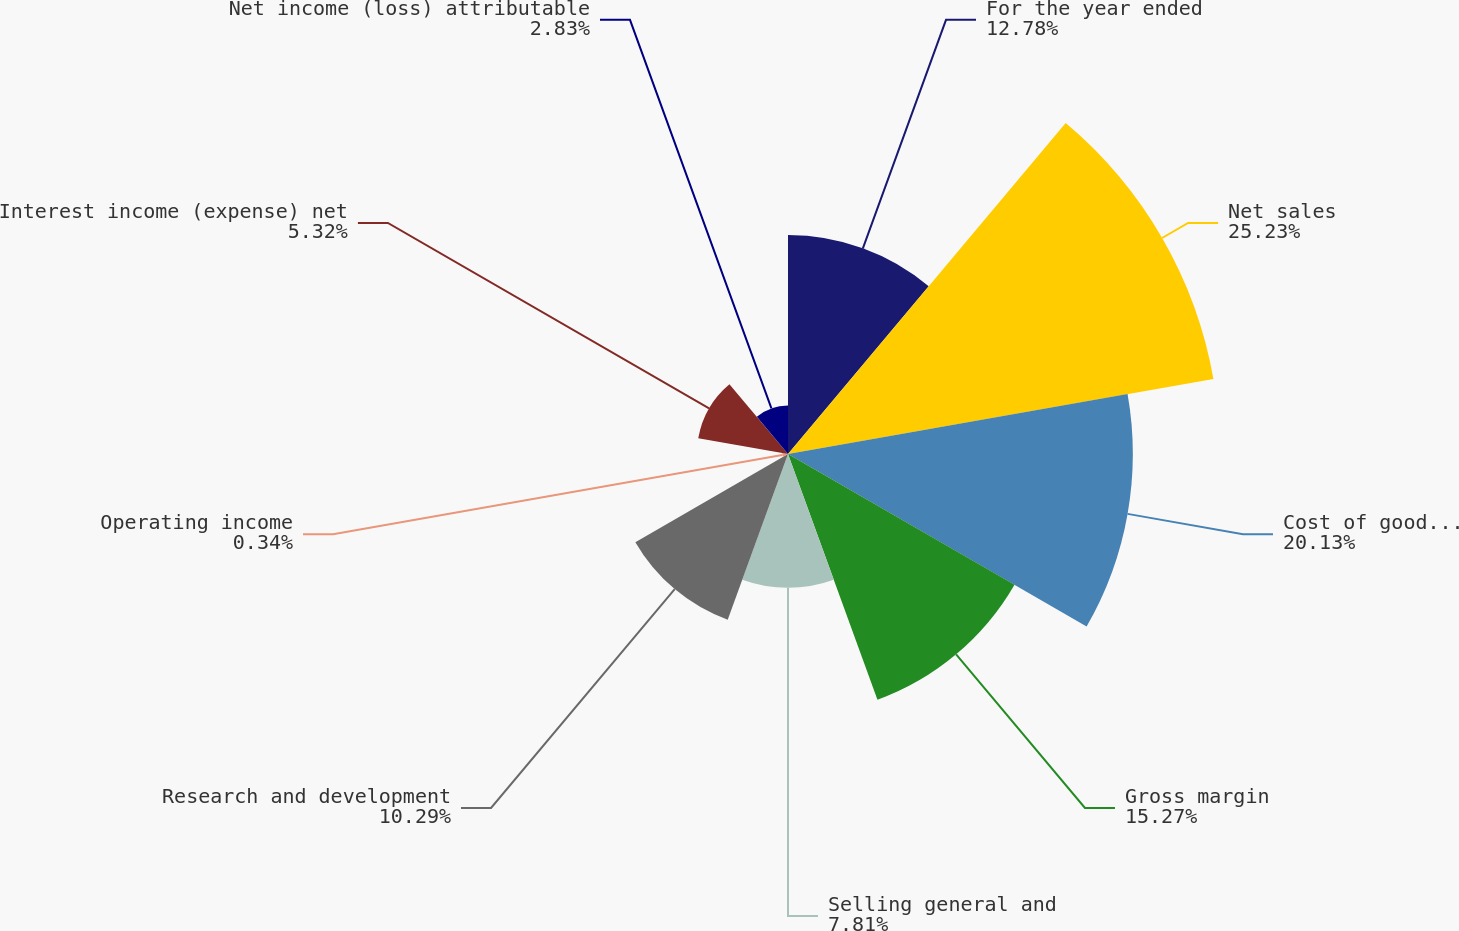Convert chart to OTSL. <chart><loc_0><loc_0><loc_500><loc_500><pie_chart><fcel>For the year ended<fcel>Net sales<fcel>Cost of goods sold<fcel>Gross margin<fcel>Selling general and<fcel>Research and development<fcel>Operating income<fcel>Interest income (expense) net<fcel>Net income (loss) attributable<nl><fcel>12.78%<fcel>25.22%<fcel>20.13%<fcel>15.27%<fcel>7.81%<fcel>10.29%<fcel>0.34%<fcel>5.32%<fcel>2.83%<nl></chart> 